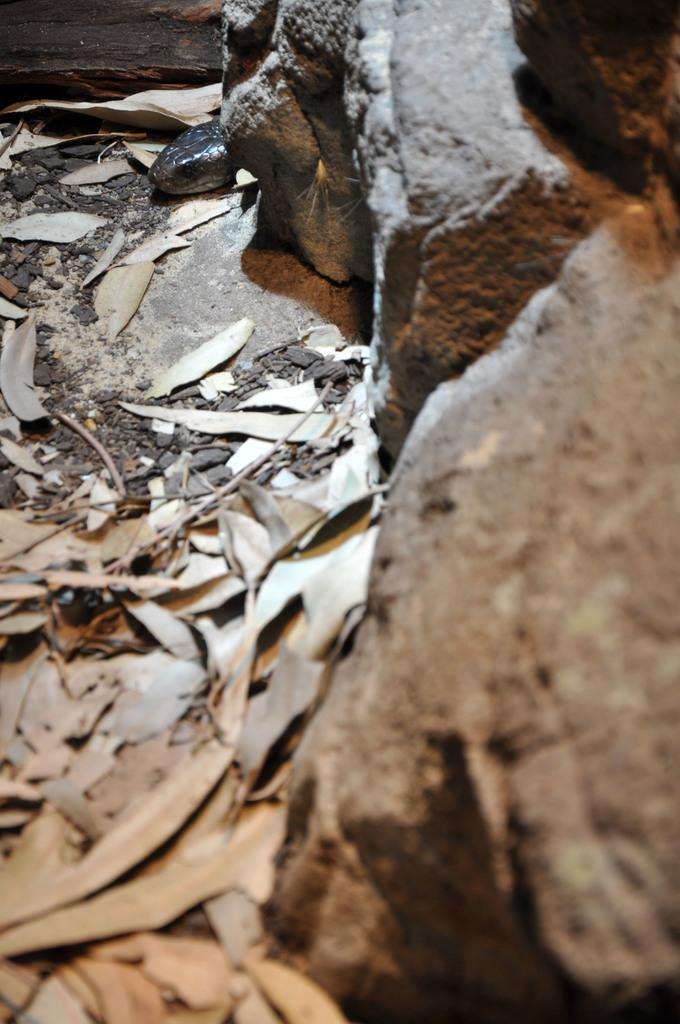What type of natural material can be seen in the image? There are dry leaves in the image. What other objects can be seen in the image? There are rocks in the image. What type of animal is visible in the image? There is a reptile visible at the top of the image. Can you describe the unspecified object at the top of the image? Unfortunately, the facts provided do not give any details about the unspecified object at the top of the image. How does the mist affect the visibility of the reptile in the image? There is no mention of mist in the image, so it cannot affect the visibility of the reptile. What date is marked on the calendar in the image? There is no calendar present in the image. 